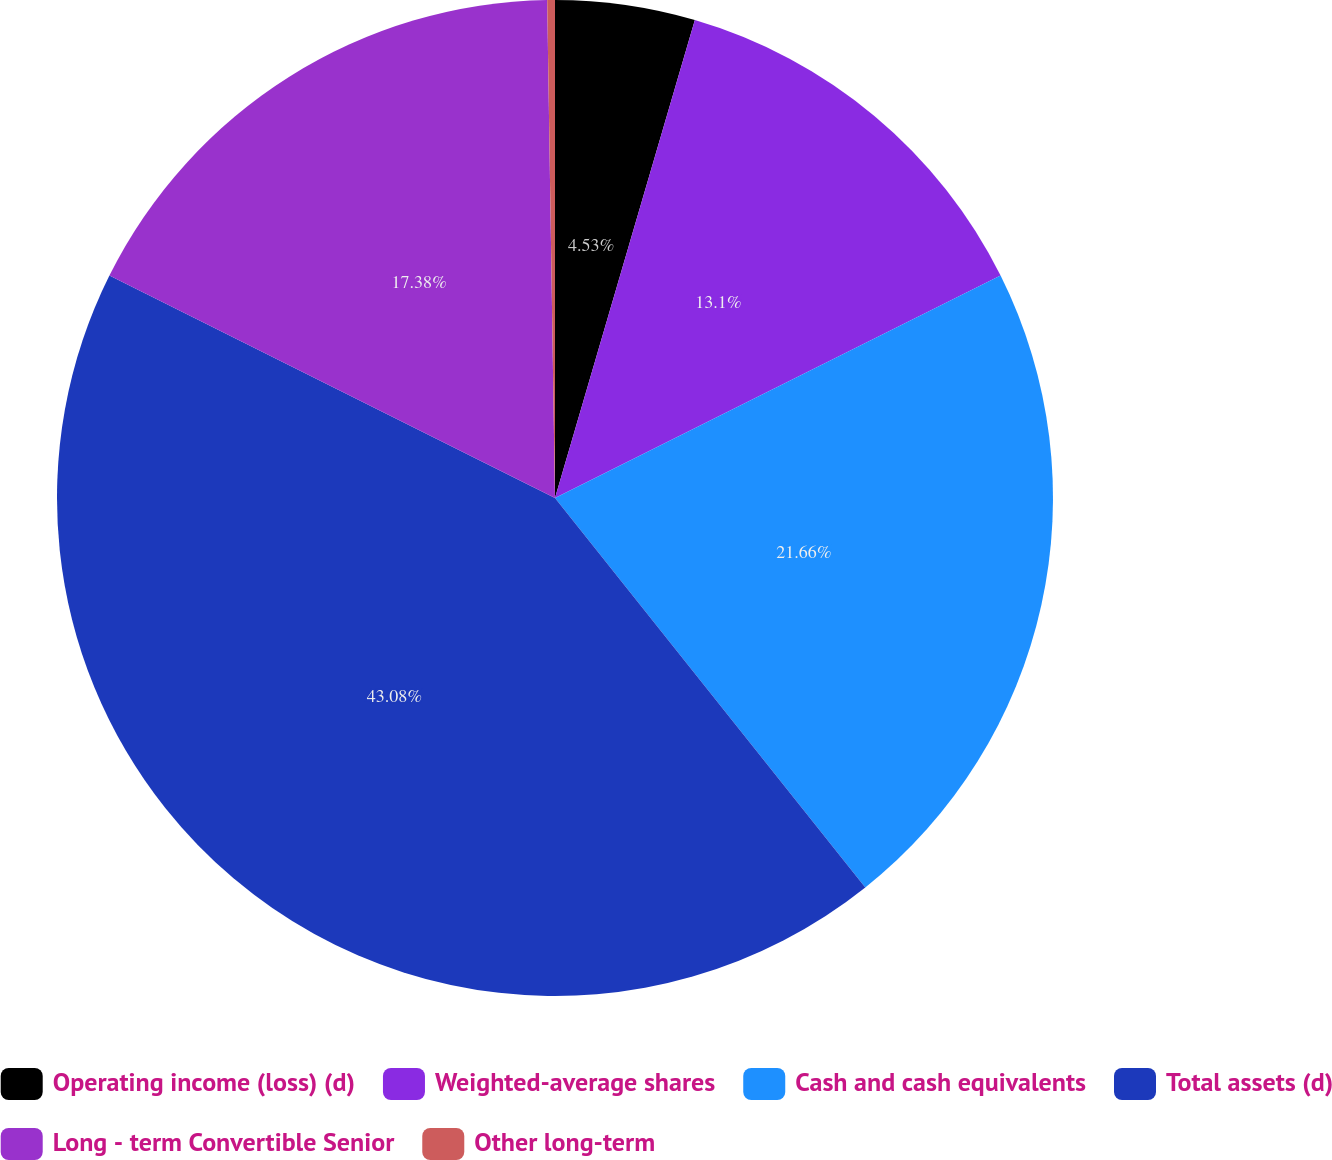<chart> <loc_0><loc_0><loc_500><loc_500><pie_chart><fcel>Operating income (loss) (d)<fcel>Weighted-average shares<fcel>Cash and cash equivalents<fcel>Total assets (d)<fcel>Long - term Convertible Senior<fcel>Other long-term<nl><fcel>4.53%<fcel>13.1%<fcel>21.66%<fcel>43.07%<fcel>17.38%<fcel>0.25%<nl></chart> 